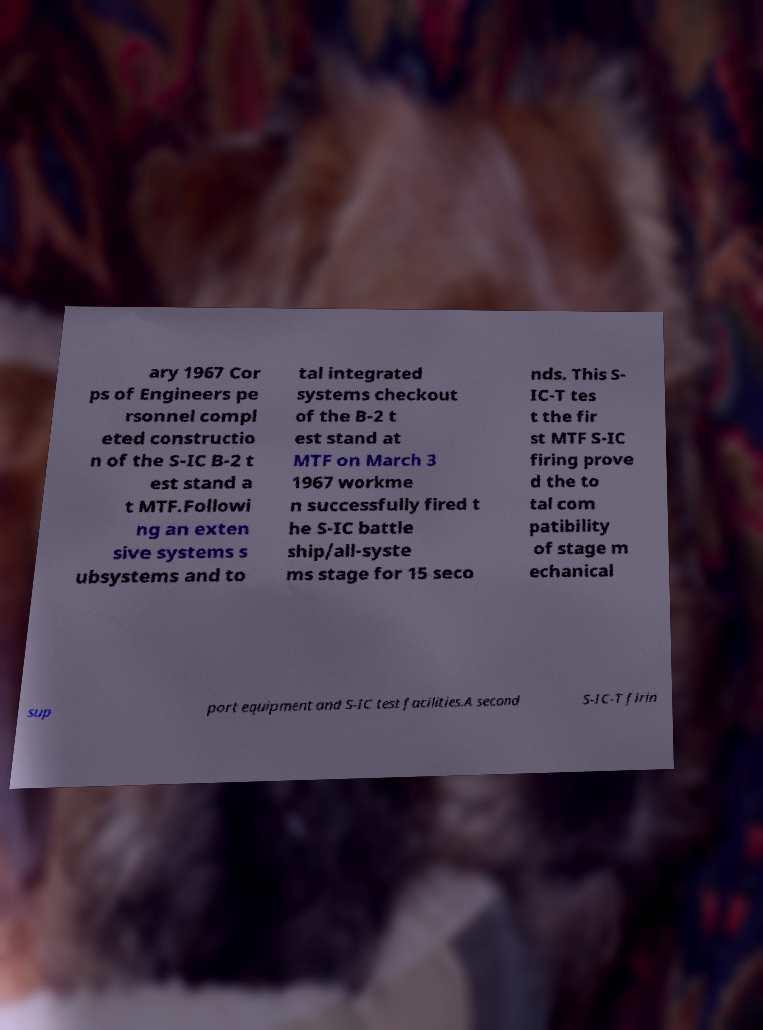Can you read and provide the text displayed in the image?This photo seems to have some interesting text. Can you extract and type it out for me? ary 1967 Cor ps of Engineers pe rsonnel compl eted constructio n of the S-IC B-2 t est stand a t MTF.Followi ng an exten sive systems s ubsystems and to tal integrated systems checkout of the B-2 t est stand at MTF on March 3 1967 workme n successfully fired t he S-IC battle ship/all-syste ms stage for 15 seco nds. This S- IC-T tes t the fir st MTF S-IC firing prove d the to tal com patibility of stage m echanical sup port equipment and S-IC test facilities.A second S-IC-T firin 